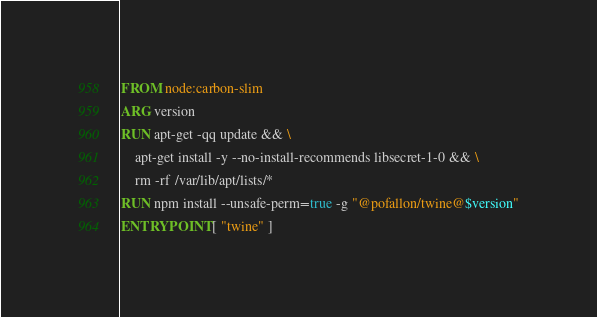Convert code to text. <code><loc_0><loc_0><loc_500><loc_500><_Dockerfile_>FROM node:carbon-slim
ARG version
RUN apt-get -qq update && \
    apt-get install -y --no-install-recommends libsecret-1-0 && \
    rm -rf /var/lib/apt/lists/*
RUN npm install --unsafe-perm=true -g "@pofallon/twine@$version"
ENTRYPOINT [ "twine" ]</code> 